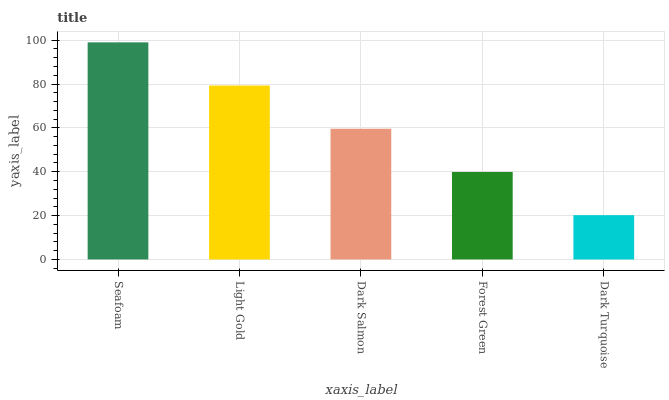Is Dark Turquoise the minimum?
Answer yes or no. Yes. Is Seafoam the maximum?
Answer yes or no. Yes. Is Light Gold the minimum?
Answer yes or no. No. Is Light Gold the maximum?
Answer yes or no. No. Is Seafoam greater than Light Gold?
Answer yes or no. Yes. Is Light Gold less than Seafoam?
Answer yes or no. Yes. Is Light Gold greater than Seafoam?
Answer yes or no. No. Is Seafoam less than Light Gold?
Answer yes or no. No. Is Dark Salmon the high median?
Answer yes or no. Yes. Is Dark Salmon the low median?
Answer yes or no. Yes. Is Seafoam the high median?
Answer yes or no. No. Is Light Gold the low median?
Answer yes or no. No. 